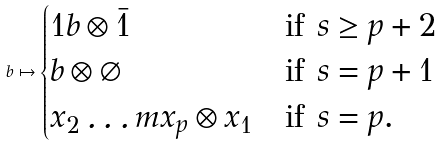<formula> <loc_0><loc_0><loc_500><loc_500>b \mapsto \begin{cases} 1 b \otimes \bar { 1 } & \text {if $s \geq p+2$} \\ b \otimes \varnothing & \text {if $s=p+1$} \\ x _ { 2 } \dots m x _ { p } \otimes x _ { 1 } & \text {if $s=p$.} \end{cases}</formula> 